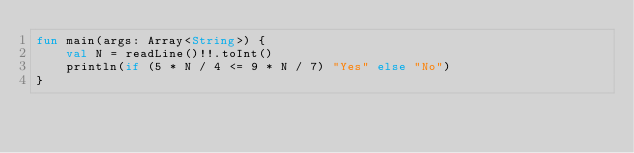<code> <loc_0><loc_0><loc_500><loc_500><_Kotlin_>fun main(args: Array<String>) {
    val N = readLine()!!.toInt()
    println(if (5 * N / 4 <= 9 * N / 7) "Yes" else "No")
}</code> 